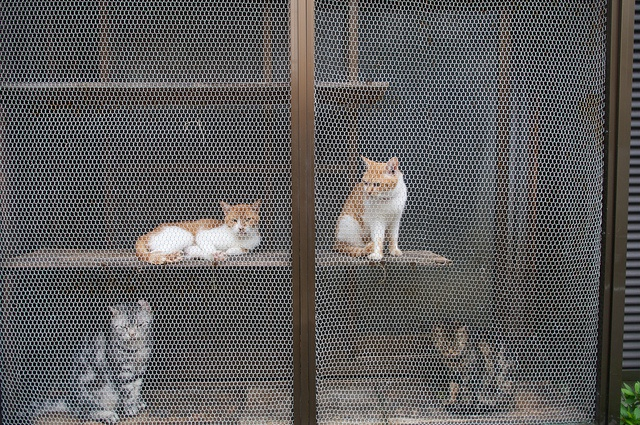Describe the objects in this image and their specific colors. I can see cat in black, darkgray, and gray tones, cat in black, darkgray, and gray tones, cat in black, darkgray, lightgray, tan, and gray tones, and cat in black, lightgray, darkgray, tan, and gray tones in this image. 